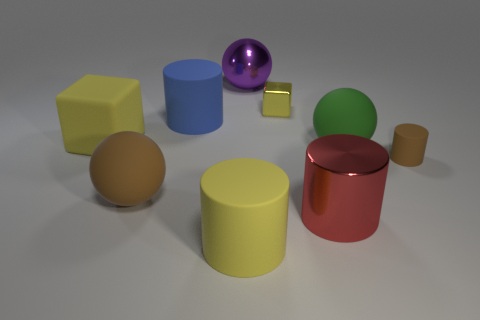How many yellow blocks must be subtracted to get 1 yellow blocks? 1 Subtract all red shiny cylinders. How many cylinders are left? 3 Add 1 small green matte blocks. How many objects exist? 10 Subtract all brown cylinders. How many cylinders are left? 3 Subtract all spheres. How many objects are left? 6 Subtract 1 blocks. How many blocks are left? 1 Subtract all brown cubes. Subtract all purple cylinders. How many cubes are left? 2 Subtract all blue cylinders. Subtract all large blue objects. How many objects are left? 7 Add 1 tiny cylinders. How many tiny cylinders are left? 2 Add 5 red metal cylinders. How many red metal cylinders exist? 6 